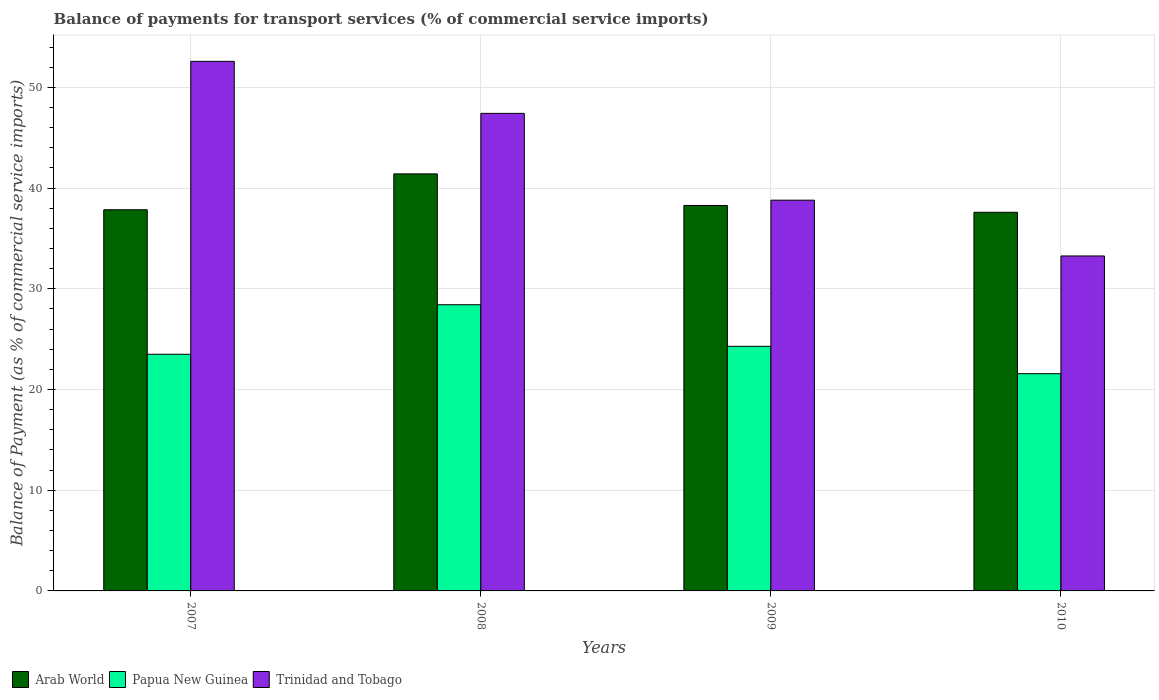How many different coloured bars are there?
Offer a very short reply. 3. How many groups of bars are there?
Provide a succinct answer. 4. Are the number of bars on each tick of the X-axis equal?
Your response must be concise. Yes. How many bars are there on the 1st tick from the left?
Your answer should be very brief. 3. How many bars are there on the 4th tick from the right?
Provide a short and direct response. 3. What is the balance of payments for transport services in Papua New Guinea in 2007?
Offer a terse response. 23.5. Across all years, what is the maximum balance of payments for transport services in Arab World?
Make the answer very short. 41.41. Across all years, what is the minimum balance of payments for transport services in Trinidad and Tobago?
Your answer should be compact. 33.26. In which year was the balance of payments for transport services in Trinidad and Tobago maximum?
Offer a terse response. 2007. In which year was the balance of payments for transport services in Arab World minimum?
Keep it short and to the point. 2010. What is the total balance of payments for transport services in Papua New Guinea in the graph?
Provide a short and direct response. 97.77. What is the difference between the balance of payments for transport services in Trinidad and Tobago in 2007 and that in 2008?
Make the answer very short. 5.16. What is the difference between the balance of payments for transport services in Trinidad and Tobago in 2007 and the balance of payments for transport services in Papua New Guinea in 2009?
Offer a terse response. 28.3. What is the average balance of payments for transport services in Trinidad and Tobago per year?
Give a very brief answer. 43.02. In the year 2007, what is the difference between the balance of payments for transport services in Papua New Guinea and balance of payments for transport services in Arab World?
Keep it short and to the point. -14.35. What is the ratio of the balance of payments for transport services in Papua New Guinea in 2009 to that in 2010?
Offer a very short reply. 1.13. Is the balance of payments for transport services in Arab World in 2007 less than that in 2008?
Provide a short and direct response. Yes. What is the difference between the highest and the second highest balance of payments for transport services in Papua New Guinea?
Provide a short and direct response. 4.13. What is the difference between the highest and the lowest balance of payments for transport services in Trinidad and Tobago?
Your answer should be very brief. 19.32. In how many years, is the balance of payments for transport services in Papua New Guinea greater than the average balance of payments for transport services in Papua New Guinea taken over all years?
Ensure brevity in your answer.  1. What does the 3rd bar from the left in 2010 represents?
Give a very brief answer. Trinidad and Tobago. What does the 2nd bar from the right in 2009 represents?
Ensure brevity in your answer.  Papua New Guinea. Is it the case that in every year, the sum of the balance of payments for transport services in Trinidad and Tobago and balance of payments for transport services in Papua New Guinea is greater than the balance of payments for transport services in Arab World?
Your answer should be very brief. Yes. Are all the bars in the graph horizontal?
Ensure brevity in your answer.  No. How many years are there in the graph?
Provide a succinct answer. 4. Does the graph contain grids?
Give a very brief answer. Yes. Where does the legend appear in the graph?
Offer a very short reply. Bottom left. What is the title of the graph?
Ensure brevity in your answer.  Balance of payments for transport services (% of commercial service imports). Does "Andorra" appear as one of the legend labels in the graph?
Ensure brevity in your answer.  No. What is the label or title of the Y-axis?
Give a very brief answer. Balance of Payment (as % of commercial service imports). What is the Balance of Payment (as % of commercial service imports) in Arab World in 2007?
Your response must be concise. 37.85. What is the Balance of Payment (as % of commercial service imports) in Papua New Guinea in 2007?
Ensure brevity in your answer.  23.5. What is the Balance of Payment (as % of commercial service imports) of Trinidad and Tobago in 2007?
Provide a succinct answer. 52.58. What is the Balance of Payment (as % of commercial service imports) in Arab World in 2008?
Your answer should be compact. 41.41. What is the Balance of Payment (as % of commercial service imports) in Papua New Guinea in 2008?
Make the answer very short. 28.42. What is the Balance of Payment (as % of commercial service imports) in Trinidad and Tobago in 2008?
Your answer should be compact. 47.42. What is the Balance of Payment (as % of commercial service imports) of Arab World in 2009?
Offer a very short reply. 38.28. What is the Balance of Payment (as % of commercial service imports) of Papua New Guinea in 2009?
Offer a very short reply. 24.29. What is the Balance of Payment (as % of commercial service imports) of Trinidad and Tobago in 2009?
Your answer should be compact. 38.8. What is the Balance of Payment (as % of commercial service imports) in Arab World in 2010?
Provide a succinct answer. 37.6. What is the Balance of Payment (as % of commercial service imports) in Papua New Guinea in 2010?
Offer a terse response. 21.57. What is the Balance of Payment (as % of commercial service imports) of Trinidad and Tobago in 2010?
Your response must be concise. 33.26. Across all years, what is the maximum Balance of Payment (as % of commercial service imports) of Arab World?
Keep it short and to the point. 41.41. Across all years, what is the maximum Balance of Payment (as % of commercial service imports) in Papua New Guinea?
Provide a succinct answer. 28.42. Across all years, what is the maximum Balance of Payment (as % of commercial service imports) in Trinidad and Tobago?
Offer a terse response. 52.58. Across all years, what is the minimum Balance of Payment (as % of commercial service imports) in Arab World?
Make the answer very short. 37.6. Across all years, what is the minimum Balance of Payment (as % of commercial service imports) of Papua New Guinea?
Offer a very short reply. 21.57. Across all years, what is the minimum Balance of Payment (as % of commercial service imports) of Trinidad and Tobago?
Your response must be concise. 33.26. What is the total Balance of Payment (as % of commercial service imports) of Arab World in the graph?
Provide a short and direct response. 155.13. What is the total Balance of Payment (as % of commercial service imports) in Papua New Guinea in the graph?
Your answer should be compact. 97.77. What is the total Balance of Payment (as % of commercial service imports) in Trinidad and Tobago in the graph?
Ensure brevity in your answer.  172.07. What is the difference between the Balance of Payment (as % of commercial service imports) in Arab World in 2007 and that in 2008?
Offer a very short reply. -3.56. What is the difference between the Balance of Payment (as % of commercial service imports) of Papua New Guinea in 2007 and that in 2008?
Provide a succinct answer. -4.92. What is the difference between the Balance of Payment (as % of commercial service imports) of Trinidad and Tobago in 2007 and that in 2008?
Provide a succinct answer. 5.16. What is the difference between the Balance of Payment (as % of commercial service imports) of Arab World in 2007 and that in 2009?
Provide a succinct answer. -0.43. What is the difference between the Balance of Payment (as % of commercial service imports) of Papua New Guinea in 2007 and that in 2009?
Give a very brief answer. -0.79. What is the difference between the Balance of Payment (as % of commercial service imports) in Trinidad and Tobago in 2007 and that in 2009?
Give a very brief answer. 13.79. What is the difference between the Balance of Payment (as % of commercial service imports) in Arab World in 2007 and that in 2010?
Give a very brief answer. 0.25. What is the difference between the Balance of Payment (as % of commercial service imports) of Papua New Guinea in 2007 and that in 2010?
Ensure brevity in your answer.  1.93. What is the difference between the Balance of Payment (as % of commercial service imports) in Trinidad and Tobago in 2007 and that in 2010?
Ensure brevity in your answer.  19.32. What is the difference between the Balance of Payment (as % of commercial service imports) of Arab World in 2008 and that in 2009?
Provide a short and direct response. 3.14. What is the difference between the Balance of Payment (as % of commercial service imports) in Papua New Guinea in 2008 and that in 2009?
Your answer should be compact. 4.13. What is the difference between the Balance of Payment (as % of commercial service imports) in Trinidad and Tobago in 2008 and that in 2009?
Offer a terse response. 8.62. What is the difference between the Balance of Payment (as % of commercial service imports) in Arab World in 2008 and that in 2010?
Your answer should be compact. 3.81. What is the difference between the Balance of Payment (as % of commercial service imports) in Papua New Guinea in 2008 and that in 2010?
Offer a terse response. 6.85. What is the difference between the Balance of Payment (as % of commercial service imports) in Trinidad and Tobago in 2008 and that in 2010?
Give a very brief answer. 14.16. What is the difference between the Balance of Payment (as % of commercial service imports) of Arab World in 2009 and that in 2010?
Keep it short and to the point. 0.68. What is the difference between the Balance of Payment (as % of commercial service imports) in Papua New Guinea in 2009 and that in 2010?
Offer a very short reply. 2.72. What is the difference between the Balance of Payment (as % of commercial service imports) of Trinidad and Tobago in 2009 and that in 2010?
Your answer should be compact. 5.54. What is the difference between the Balance of Payment (as % of commercial service imports) in Arab World in 2007 and the Balance of Payment (as % of commercial service imports) in Papua New Guinea in 2008?
Provide a succinct answer. 9.43. What is the difference between the Balance of Payment (as % of commercial service imports) of Arab World in 2007 and the Balance of Payment (as % of commercial service imports) of Trinidad and Tobago in 2008?
Keep it short and to the point. -9.57. What is the difference between the Balance of Payment (as % of commercial service imports) in Papua New Guinea in 2007 and the Balance of Payment (as % of commercial service imports) in Trinidad and Tobago in 2008?
Make the answer very short. -23.92. What is the difference between the Balance of Payment (as % of commercial service imports) of Arab World in 2007 and the Balance of Payment (as % of commercial service imports) of Papua New Guinea in 2009?
Offer a terse response. 13.56. What is the difference between the Balance of Payment (as % of commercial service imports) of Arab World in 2007 and the Balance of Payment (as % of commercial service imports) of Trinidad and Tobago in 2009?
Your response must be concise. -0.95. What is the difference between the Balance of Payment (as % of commercial service imports) of Papua New Guinea in 2007 and the Balance of Payment (as % of commercial service imports) of Trinidad and Tobago in 2009?
Give a very brief answer. -15.3. What is the difference between the Balance of Payment (as % of commercial service imports) in Arab World in 2007 and the Balance of Payment (as % of commercial service imports) in Papua New Guinea in 2010?
Your answer should be very brief. 16.28. What is the difference between the Balance of Payment (as % of commercial service imports) of Arab World in 2007 and the Balance of Payment (as % of commercial service imports) of Trinidad and Tobago in 2010?
Keep it short and to the point. 4.59. What is the difference between the Balance of Payment (as % of commercial service imports) in Papua New Guinea in 2007 and the Balance of Payment (as % of commercial service imports) in Trinidad and Tobago in 2010?
Your answer should be compact. -9.76. What is the difference between the Balance of Payment (as % of commercial service imports) of Arab World in 2008 and the Balance of Payment (as % of commercial service imports) of Papua New Guinea in 2009?
Ensure brevity in your answer.  17.12. What is the difference between the Balance of Payment (as % of commercial service imports) in Arab World in 2008 and the Balance of Payment (as % of commercial service imports) in Trinidad and Tobago in 2009?
Your answer should be very brief. 2.61. What is the difference between the Balance of Payment (as % of commercial service imports) in Papua New Guinea in 2008 and the Balance of Payment (as % of commercial service imports) in Trinidad and Tobago in 2009?
Your response must be concise. -10.38. What is the difference between the Balance of Payment (as % of commercial service imports) of Arab World in 2008 and the Balance of Payment (as % of commercial service imports) of Papua New Guinea in 2010?
Offer a very short reply. 19.84. What is the difference between the Balance of Payment (as % of commercial service imports) in Arab World in 2008 and the Balance of Payment (as % of commercial service imports) in Trinidad and Tobago in 2010?
Offer a terse response. 8.15. What is the difference between the Balance of Payment (as % of commercial service imports) in Papua New Guinea in 2008 and the Balance of Payment (as % of commercial service imports) in Trinidad and Tobago in 2010?
Offer a terse response. -4.85. What is the difference between the Balance of Payment (as % of commercial service imports) in Arab World in 2009 and the Balance of Payment (as % of commercial service imports) in Papua New Guinea in 2010?
Ensure brevity in your answer.  16.71. What is the difference between the Balance of Payment (as % of commercial service imports) of Arab World in 2009 and the Balance of Payment (as % of commercial service imports) of Trinidad and Tobago in 2010?
Make the answer very short. 5.01. What is the difference between the Balance of Payment (as % of commercial service imports) in Papua New Guinea in 2009 and the Balance of Payment (as % of commercial service imports) in Trinidad and Tobago in 2010?
Provide a succinct answer. -8.97. What is the average Balance of Payment (as % of commercial service imports) in Arab World per year?
Your answer should be compact. 38.78. What is the average Balance of Payment (as % of commercial service imports) in Papua New Guinea per year?
Provide a short and direct response. 24.44. What is the average Balance of Payment (as % of commercial service imports) of Trinidad and Tobago per year?
Keep it short and to the point. 43.02. In the year 2007, what is the difference between the Balance of Payment (as % of commercial service imports) of Arab World and Balance of Payment (as % of commercial service imports) of Papua New Guinea?
Your answer should be compact. 14.35. In the year 2007, what is the difference between the Balance of Payment (as % of commercial service imports) of Arab World and Balance of Payment (as % of commercial service imports) of Trinidad and Tobago?
Offer a very short reply. -14.74. In the year 2007, what is the difference between the Balance of Payment (as % of commercial service imports) of Papua New Guinea and Balance of Payment (as % of commercial service imports) of Trinidad and Tobago?
Provide a short and direct response. -29.09. In the year 2008, what is the difference between the Balance of Payment (as % of commercial service imports) of Arab World and Balance of Payment (as % of commercial service imports) of Papua New Guinea?
Give a very brief answer. 13. In the year 2008, what is the difference between the Balance of Payment (as % of commercial service imports) in Arab World and Balance of Payment (as % of commercial service imports) in Trinidad and Tobago?
Your answer should be very brief. -6.01. In the year 2008, what is the difference between the Balance of Payment (as % of commercial service imports) of Papua New Guinea and Balance of Payment (as % of commercial service imports) of Trinidad and Tobago?
Make the answer very short. -19. In the year 2009, what is the difference between the Balance of Payment (as % of commercial service imports) in Arab World and Balance of Payment (as % of commercial service imports) in Papua New Guinea?
Offer a terse response. 13.99. In the year 2009, what is the difference between the Balance of Payment (as % of commercial service imports) of Arab World and Balance of Payment (as % of commercial service imports) of Trinidad and Tobago?
Offer a very short reply. -0.52. In the year 2009, what is the difference between the Balance of Payment (as % of commercial service imports) of Papua New Guinea and Balance of Payment (as % of commercial service imports) of Trinidad and Tobago?
Offer a terse response. -14.51. In the year 2010, what is the difference between the Balance of Payment (as % of commercial service imports) of Arab World and Balance of Payment (as % of commercial service imports) of Papua New Guinea?
Make the answer very short. 16.03. In the year 2010, what is the difference between the Balance of Payment (as % of commercial service imports) in Arab World and Balance of Payment (as % of commercial service imports) in Trinidad and Tobago?
Ensure brevity in your answer.  4.34. In the year 2010, what is the difference between the Balance of Payment (as % of commercial service imports) in Papua New Guinea and Balance of Payment (as % of commercial service imports) in Trinidad and Tobago?
Give a very brief answer. -11.69. What is the ratio of the Balance of Payment (as % of commercial service imports) of Arab World in 2007 to that in 2008?
Give a very brief answer. 0.91. What is the ratio of the Balance of Payment (as % of commercial service imports) of Papua New Guinea in 2007 to that in 2008?
Your answer should be compact. 0.83. What is the ratio of the Balance of Payment (as % of commercial service imports) of Trinidad and Tobago in 2007 to that in 2008?
Offer a very short reply. 1.11. What is the ratio of the Balance of Payment (as % of commercial service imports) in Papua New Guinea in 2007 to that in 2009?
Keep it short and to the point. 0.97. What is the ratio of the Balance of Payment (as % of commercial service imports) of Trinidad and Tobago in 2007 to that in 2009?
Give a very brief answer. 1.36. What is the ratio of the Balance of Payment (as % of commercial service imports) of Arab World in 2007 to that in 2010?
Give a very brief answer. 1.01. What is the ratio of the Balance of Payment (as % of commercial service imports) of Papua New Guinea in 2007 to that in 2010?
Ensure brevity in your answer.  1.09. What is the ratio of the Balance of Payment (as % of commercial service imports) of Trinidad and Tobago in 2007 to that in 2010?
Offer a terse response. 1.58. What is the ratio of the Balance of Payment (as % of commercial service imports) in Arab World in 2008 to that in 2009?
Your response must be concise. 1.08. What is the ratio of the Balance of Payment (as % of commercial service imports) in Papua New Guinea in 2008 to that in 2009?
Provide a succinct answer. 1.17. What is the ratio of the Balance of Payment (as % of commercial service imports) in Trinidad and Tobago in 2008 to that in 2009?
Ensure brevity in your answer.  1.22. What is the ratio of the Balance of Payment (as % of commercial service imports) of Arab World in 2008 to that in 2010?
Ensure brevity in your answer.  1.1. What is the ratio of the Balance of Payment (as % of commercial service imports) of Papua New Guinea in 2008 to that in 2010?
Ensure brevity in your answer.  1.32. What is the ratio of the Balance of Payment (as % of commercial service imports) of Trinidad and Tobago in 2008 to that in 2010?
Offer a very short reply. 1.43. What is the ratio of the Balance of Payment (as % of commercial service imports) of Arab World in 2009 to that in 2010?
Keep it short and to the point. 1.02. What is the ratio of the Balance of Payment (as % of commercial service imports) in Papua New Guinea in 2009 to that in 2010?
Your answer should be very brief. 1.13. What is the ratio of the Balance of Payment (as % of commercial service imports) of Trinidad and Tobago in 2009 to that in 2010?
Ensure brevity in your answer.  1.17. What is the difference between the highest and the second highest Balance of Payment (as % of commercial service imports) in Arab World?
Your response must be concise. 3.14. What is the difference between the highest and the second highest Balance of Payment (as % of commercial service imports) of Papua New Guinea?
Your answer should be compact. 4.13. What is the difference between the highest and the second highest Balance of Payment (as % of commercial service imports) in Trinidad and Tobago?
Your response must be concise. 5.16. What is the difference between the highest and the lowest Balance of Payment (as % of commercial service imports) of Arab World?
Give a very brief answer. 3.81. What is the difference between the highest and the lowest Balance of Payment (as % of commercial service imports) of Papua New Guinea?
Your answer should be very brief. 6.85. What is the difference between the highest and the lowest Balance of Payment (as % of commercial service imports) of Trinidad and Tobago?
Make the answer very short. 19.32. 